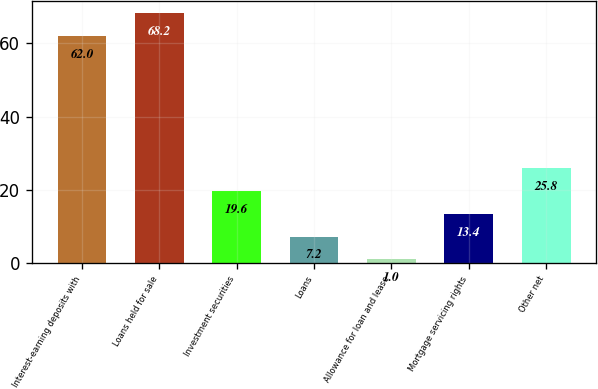<chart> <loc_0><loc_0><loc_500><loc_500><bar_chart><fcel>Interest-earning deposits with<fcel>Loans held for sale<fcel>Investment securities<fcel>Loans<fcel>Allowance for loan and lease<fcel>Mortgage servicing rights<fcel>Other net<nl><fcel>62<fcel>68.2<fcel>19.6<fcel>7.2<fcel>1<fcel>13.4<fcel>25.8<nl></chart> 